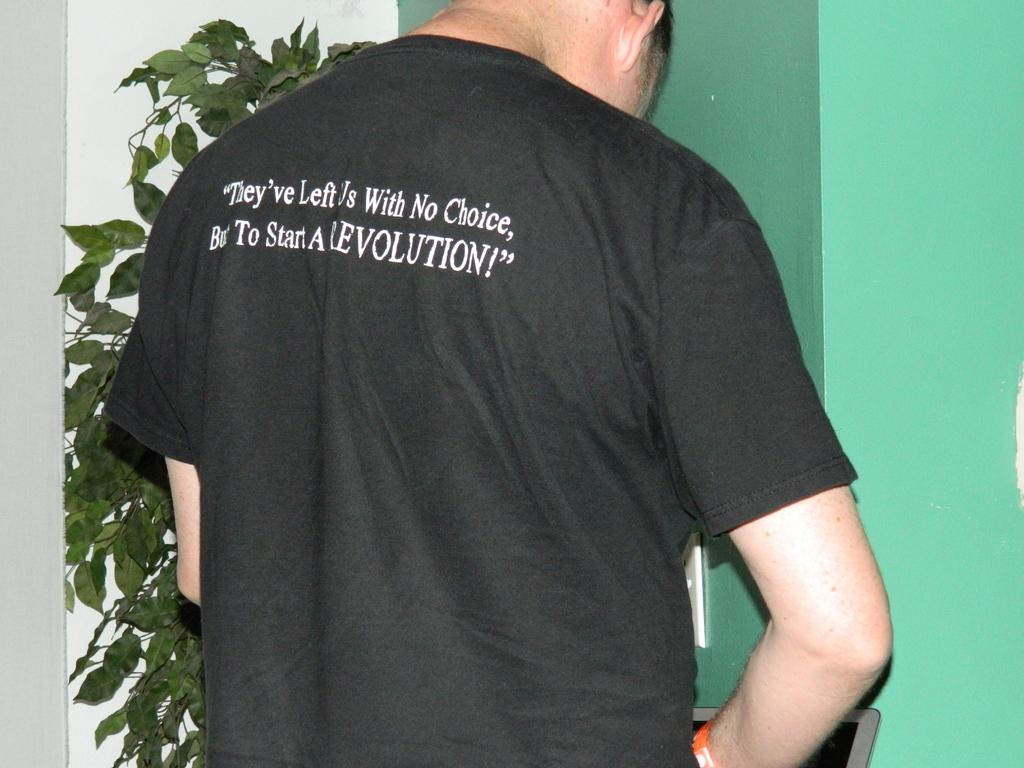<image>
Provide a brief description of the given image. A man wears a black t-shirt that contains a message about it being time to start a revolution. 